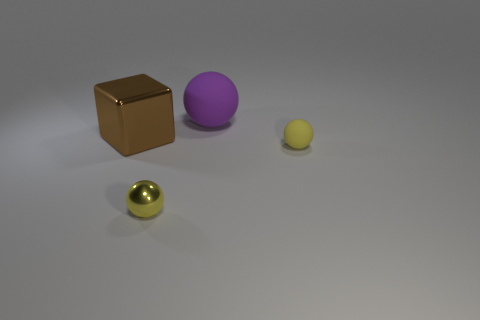What textures are apparent in this image? The objects in the image each have a distinct texture. The golden sphere has a glossy finish that reflects light, giving it a smooth and polished appearance. The brown cube looks to have a matte finish with slight reflections, indicating a less smooth surface, possibly brushed metal. The purple and yellow spheres have uniformly matte surfaces with no reflections, suggesting a non-metallic, perhaps plastic or painted texture. 